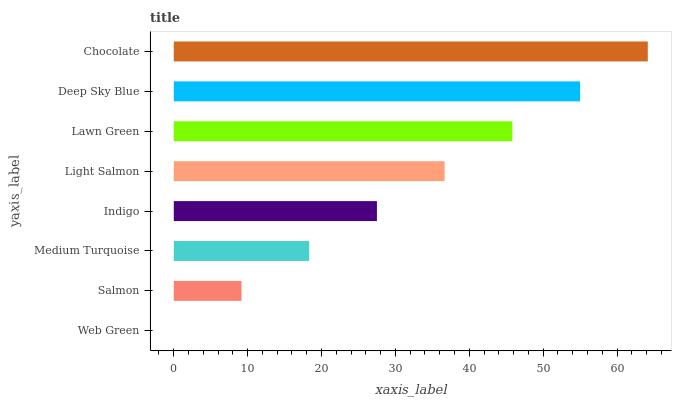Is Web Green the minimum?
Answer yes or no. Yes. Is Chocolate the maximum?
Answer yes or no. Yes. Is Salmon the minimum?
Answer yes or no. No. Is Salmon the maximum?
Answer yes or no. No. Is Salmon greater than Web Green?
Answer yes or no. Yes. Is Web Green less than Salmon?
Answer yes or no. Yes. Is Web Green greater than Salmon?
Answer yes or no. No. Is Salmon less than Web Green?
Answer yes or no. No. Is Light Salmon the high median?
Answer yes or no. Yes. Is Indigo the low median?
Answer yes or no. Yes. Is Medium Turquoise the high median?
Answer yes or no. No. Is Chocolate the low median?
Answer yes or no. No. 